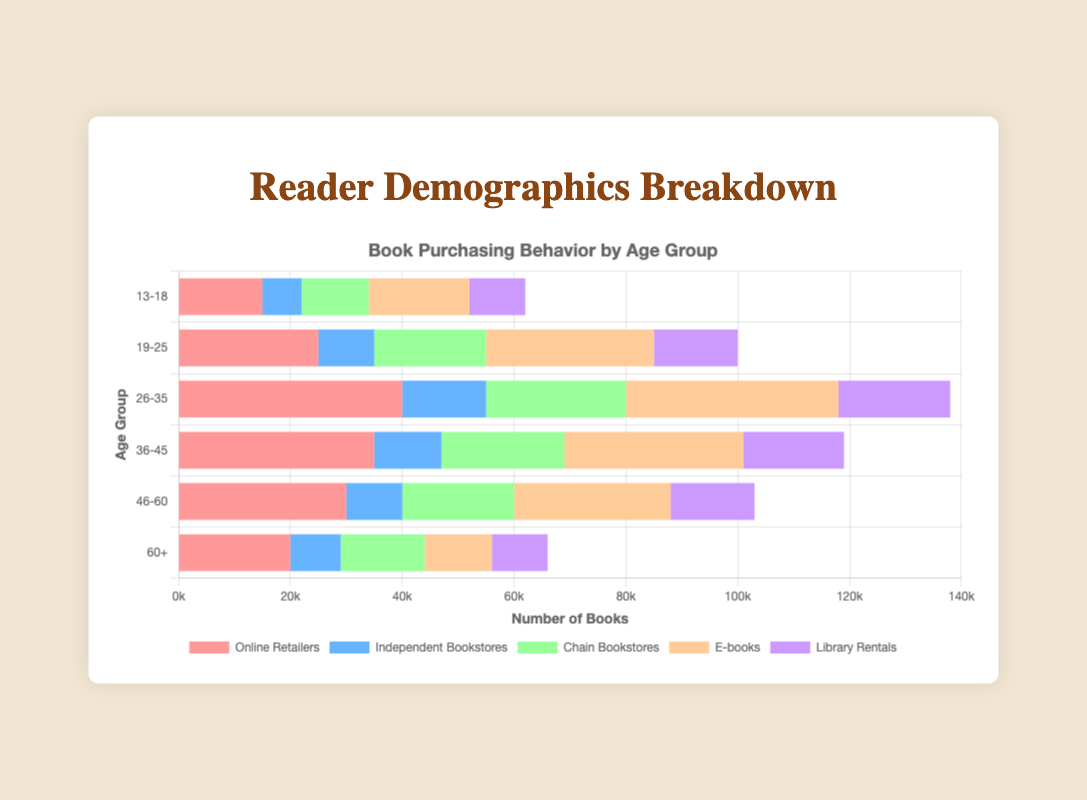How many more books do readers aged 26-35 purchase from online retailers compared to those aged 13-18? Readers aged 26-35 purchase 40,000 books from online retailers, whereas those aged 13-18 purchase 15,000 books. The difference is 40,000 - 15,000 = 25,000 books.
Answer: 25,000 Which age group rents the most books from libraries? By examining the bars for "Library Rentals", the 26-35 age group has the highest bar, indicating they rent 20,000 books which is more than any other age group.
Answer: 26-35 Among the different age groups, who purchase the fewest books from independent bookstores? By looking at the bars for "Independent Bookstores", the 13-18 age group has the smallest bar, purchasing 7,000 books which is the fewest among all age groups.
Answer: 13-18 For age group 36-45, compare the number of books purchased from chain bookstores to those rented from libraries. The number of books purchased from chain bookstores for the 36-45 age group is 22,000, while library rentals are 18,000. 22,000 is greater than 18,000.
Answer: More from chain bookstores Which category has the highest purchasing behavior for age group 19-25? In the 19-25 age group, the "E-books" bar is the longest, indicating it has the highest value of 30,000 books.
Answer: E-books What is the total number of books purchased by the age group 46-60 from online retailers and e-books combined? The age group 46-60 buys 30,000 books from online retailers and 28,000 books as e-books. The total is 30,000 + 28,000 = 58,000 books.
Answer: 58,000 Compare the purchasing behavior of chain bookstores for age groups 26-35 and 60+. Age group 26-35 purchases 25,000 books from chain bookstores, while age group 60+ purchases 15,000 books. 25,000 is greater than 15,000.
Answer: Age group 26-35 purchases more What is the average number of books purchased from online retailers across all age groups? The number of books purchased from online retailers are: 15,000 (13-18), 25,000 (19-25), 40,000 (26-35), 35,000 (36-45), 30,000 (46-60), and 20,000 (60+). The total is 15,000 + 25,000 + 40,000 + 35,000 + 30,000 + 20,000 = 165,000. The average is 165,000 / 6 = 27,500.
Answer: 27,500 